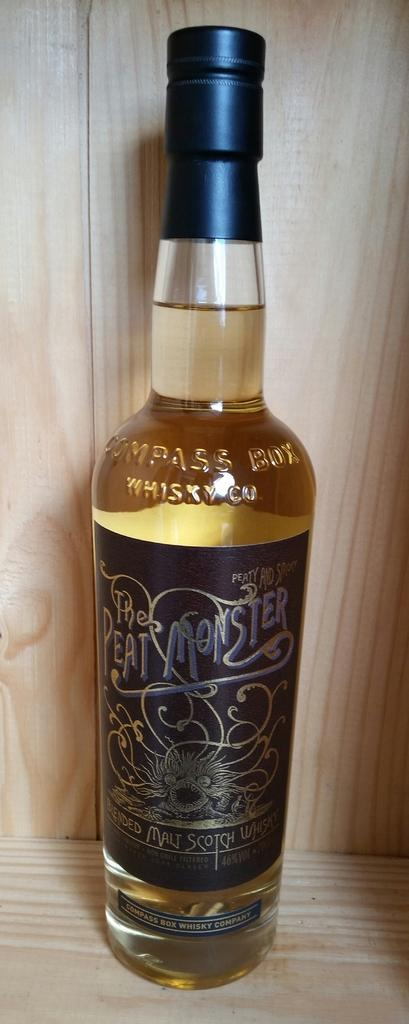What is the main object in the image? There is a beer bottle in the image. What can be seen on the beer bottle? The beer bottle has a label and a lid. Where is the beer bottle located? The beer bottle is placed in a wooden cupboard. What is the name of the thunderstorm mentioned on the beer bottle label? There is no mention of a thunderstorm or any name on the beer bottle label in the image. 